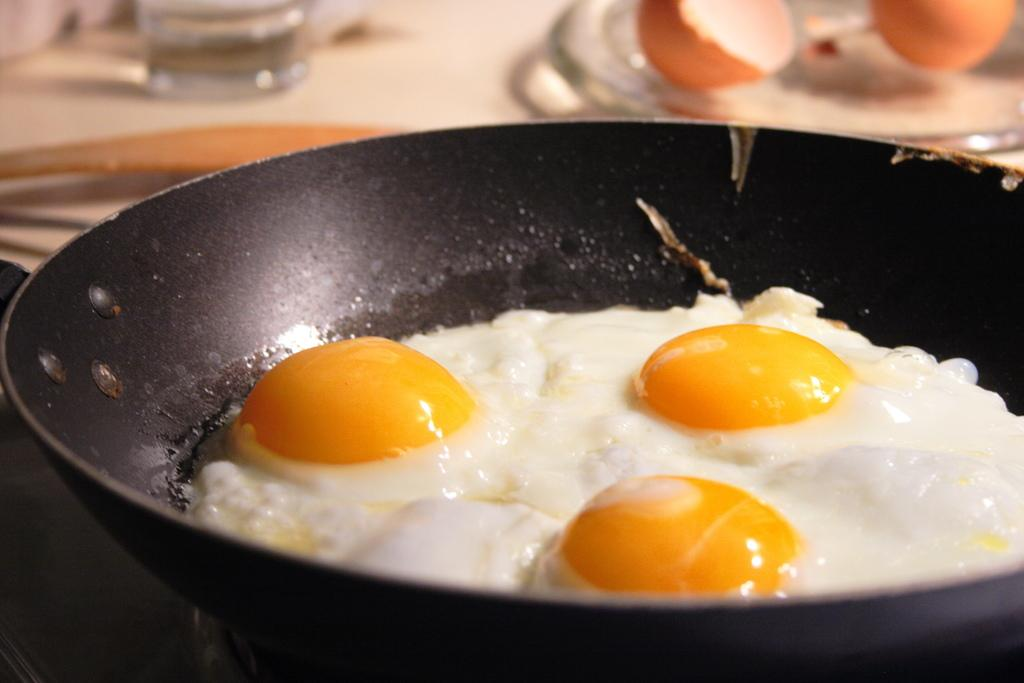What is in the pan that is visible in the image? There is a pan with food in the image. What is in the glass that is visible in the image? There is a glass with water in the image. What is on the plate that is visible in the image? There is a plate with eggs in the image. What utensil is visible in the image? A spoon is visible in the image. Where are all of these objects placed in the image? All of these objects are placed on a platform. How far away is the volcano from the platform in the image? There is no volcano present in the image, so it is not possible to determine the distance between a volcano and the platform. What type of match is used to light the stove in the image? There is no stove or match present in the image, so it is not possible to determine the type of match used. 